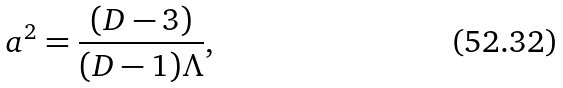Convert formula to latex. <formula><loc_0><loc_0><loc_500><loc_500>a ^ { 2 } = \frac { ( D - 3 ) } { ( D - 1 ) \Lambda } ,</formula> 